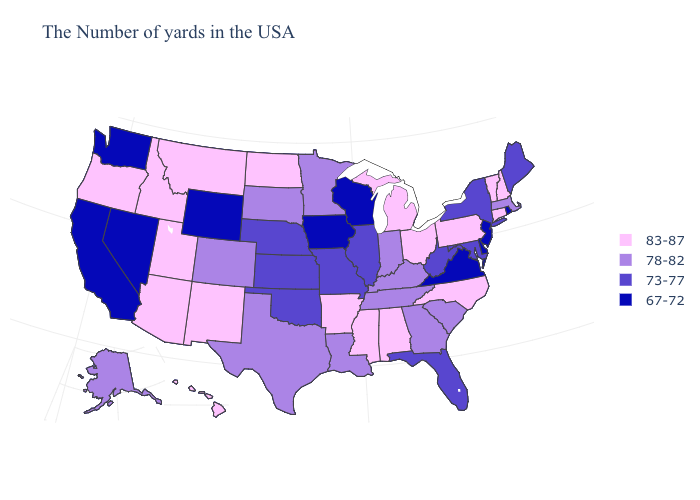How many symbols are there in the legend?
Write a very short answer. 4. Does Ohio have the highest value in the USA?
Give a very brief answer. Yes. Name the states that have a value in the range 78-82?
Short answer required. Massachusetts, South Carolina, Georgia, Kentucky, Indiana, Tennessee, Louisiana, Minnesota, Texas, South Dakota, Colorado, Alaska. Name the states that have a value in the range 83-87?
Answer briefly. New Hampshire, Vermont, Connecticut, Pennsylvania, North Carolina, Ohio, Michigan, Alabama, Mississippi, Arkansas, North Dakota, New Mexico, Utah, Montana, Arizona, Idaho, Oregon, Hawaii. Which states have the lowest value in the MidWest?
Answer briefly. Wisconsin, Iowa. Name the states that have a value in the range 67-72?
Concise answer only. Rhode Island, New Jersey, Delaware, Virginia, Wisconsin, Iowa, Wyoming, Nevada, California, Washington. What is the value of California?
Be succinct. 67-72. What is the value of Nevada?
Quick response, please. 67-72. Name the states that have a value in the range 73-77?
Concise answer only. Maine, New York, Maryland, West Virginia, Florida, Illinois, Missouri, Kansas, Nebraska, Oklahoma. Among the states that border Tennessee , does Arkansas have the lowest value?
Keep it brief. No. Name the states that have a value in the range 78-82?
Quick response, please. Massachusetts, South Carolina, Georgia, Kentucky, Indiana, Tennessee, Louisiana, Minnesota, Texas, South Dakota, Colorado, Alaska. Does North Carolina have the same value as Colorado?
Concise answer only. No. What is the value of Louisiana?
Answer briefly. 78-82. Name the states that have a value in the range 67-72?
Concise answer only. Rhode Island, New Jersey, Delaware, Virginia, Wisconsin, Iowa, Wyoming, Nevada, California, Washington. What is the value of Nevada?
Short answer required. 67-72. 